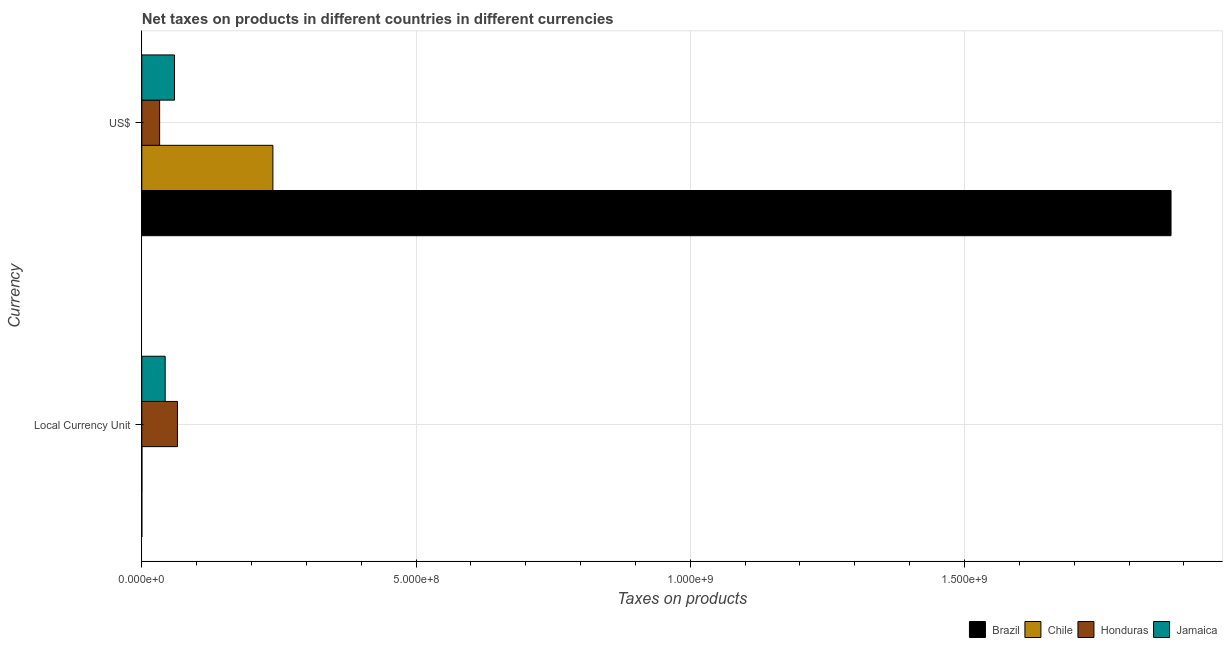How many different coloured bars are there?
Keep it short and to the point. 4. How many groups of bars are there?
Offer a terse response. 2. Are the number of bars per tick equal to the number of legend labels?
Give a very brief answer. Yes. How many bars are there on the 1st tick from the top?
Offer a very short reply. 4. How many bars are there on the 2nd tick from the bottom?
Your response must be concise. 4. What is the label of the 1st group of bars from the top?
Your answer should be very brief. US$. What is the net taxes in us$ in Honduras?
Your answer should be compact. 3.25e+07. Across all countries, what is the maximum net taxes in constant 2005 us$?
Make the answer very short. 6.50e+07. Across all countries, what is the minimum net taxes in us$?
Your answer should be very brief. 3.25e+07. In which country was the net taxes in constant 2005 us$ maximum?
Make the answer very short. Honduras. In which country was the net taxes in constant 2005 us$ minimum?
Give a very brief answer. Brazil. What is the total net taxes in constant 2005 us$ in the graph?
Your answer should be compact. 1.08e+08. What is the difference between the net taxes in constant 2005 us$ in Brazil and that in Chile?
Keep it short and to the point. -2.53e+05. What is the difference between the net taxes in constant 2005 us$ in Brazil and the net taxes in us$ in Chile?
Keep it short and to the point. -2.39e+08. What is the average net taxes in us$ per country?
Offer a terse response. 5.52e+08. What is the difference between the net taxes in us$ and net taxes in constant 2005 us$ in Honduras?
Your answer should be compact. -3.25e+07. What is the ratio of the net taxes in constant 2005 us$ in Chile to that in Honduras?
Offer a terse response. 0. Is the net taxes in constant 2005 us$ in Honduras less than that in Jamaica?
Ensure brevity in your answer.  No. In how many countries, is the net taxes in constant 2005 us$ greater than the average net taxes in constant 2005 us$ taken over all countries?
Your response must be concise. 2. What does the 2nd bar from the top in US$ represents?
Provide a succinct answer. Honduras. What does the 3rd bar from the bottom in US$ represents?
Provide a short and direct response. Honduras. How many bars are there?
Give a very brief answer. 8. How many countries are there in the graph?
Provide a succinct answer. 4. What is the difference between two consecutive major ticks on the X-axis?
Your answer should be very brief. 5.00e+08. Are the values on the major ticks of X-axis written in scientific E-notation?
Your response must be concise. Yes. Does the graph contain any zero values?
Offer a terse response. No. Does the graph contain grids?
Provide a succinct answer. Yes. Where does the legend appear in the graph?
Offer a terse response. Bottom right. How are the legend labels stacked?
Your response must be concise. Horizontal. What is the title of the graph?
Keep it short and to the point. Net taxes on products in different countries in different currencies. What is the label or title of the X-axis?
Give a very brief answer. Taxes on products. What is the label or title of the Y-axis?
Your response must be concise. Currency. What is the Taxes on products of Brazil in Local Currency Unit?
Ensure brevity in your answer.  0. What is the Taxes on products of Chile in Local Currency Unit?
Ensure brevity in your answer.  2.53e+05. What is the Taxes on products of Honduras in Local Currency Unit?
Keep it short and to the point. 6.50e+07. What is the Taxes on products of Jamaica in Local Currency Unit?
Keep it short and to the point. 4.26e+07. What is the Taxes on products in Brazil in US$?
Offer a very short reply. 1.88e+09. What is the Taxes on products in Chile in US$?
Provide a succinct answer. 2.39e+08. What is the Taxes on products of Honduras in US$?
Give a very brief answer. 3.25e+07. What is the Taxes on products in Jamaica in US$?
Your answer should be compact. 5.96e+07. Across all Currency, what is the maximum Taxes on products in Brazil?
Provide a short and direct response. 1.88e+09. Across all Currency, what is the maximum Taxes on products of Chile?
Ensure brevity in your answer.  2.39e+08. Across all Currency, what is the maximum Taxes on products in Honduras?
Your answer should be compact. 6.50e+07. Across all Currency, what is the maximum Taxes on products in Jamaica?
Your answer should be compact. 5.96e+07. Across all Currency, what is the minimum Taxes on products in Brazil?
Your answer should be very brief. 0. Across all Currency, what is the minimum Taxes on products of Chile?
Give a very brief answer. 2.53e+05. Across all Currency, what is the minimum Taxes on products of Honduras?
Make the answer very short. 3.25e+07. Across all Currency, what is the minimum Taxes on products of Jamaica?
Your answer should be very brief. 4.26e+07. What is the total Taxes on products in Brazil in the graph?
Ensure brevity in your answer.  1.88e+09. What is the total Taxes on products of Chile in the graph?
Keep it short and to the point. 2.39e+08. What is the total Taxes on products of Honduras in the graph?
Your answer should be compact. 9.75e+07. What is the total Taxes on products in Jamaica in the graph?
Provide a short and direct response. 1.02e+08. What is the difference between the Taxes on products in Brazil in Local Currency Unit and that in US$?
Give a very brief answer. -1.88e+09. What is the difference between the Taxes on products of Chile in Local Currency Unit and that in US$?
Your answer should be compact. -2.39e+08. What is the difference between the Taxes on products in Honduras in Local Currency Unit and that in US$?
Your answer should be compact. 3.25e+07. What is the difference between the Taxes on products of Jamaica in Local Currency Unit and that in US$?
Your answer should be compact. -1.70e+07. What is the difference between the Taxes on products of Brazil in Local Currency Unit and the Taxes on products of Chile in US$?
Make the answer very short. -2.39e+08. What is the difference between the Taxes on products of Brazil in Local Currency Unit and the Taxes on products of Honduras in US$?
Your answer should be very brief. -3.25e+07. What is the difference between the Taxes on products in Brazil in Local Currency Unit and the Taxes on products in Jamaica in US$?
Offer a very short reply. -5.96e+07. What is the difference between the Taxes on products in Chile in Local Currency Unit and the Taxes on products in Honduras in US$?
Make the answer very short. -3.22e+07. What is the difference between the Taxes on products in Chile in Local Currency Unit and the Taxes on products in Jamaica in US$?
Offer a very short reply. -5.94e+07. What is the difference between the Taxes on products in Honduras in Local Currency Unit and the Taxes on products in Jamaica in US$?
Offer a very short reply. 5.36e+06. What is the average Taxes on products in Brazil per Currency?
Offer a very short reply. 9.38e+08. What is the average Taxes on products in Chile per Currency?
Your response must be concise. 1.20e+08. What is the average Taxes on products of Honduras per Currency?
Your answer should be compact. 4.88e+07. What is the average Taxes on products in Jamaica per Currency?
Provide a succinct answer. 5.11e+07. What is the difference between the Taxes on products in Brazil and Taxes on products in Chile in Local Currency Unit?
Give a very brief answer. -2.53e+05. What is the difference between the Taxes on products in Brazil and Taxes on products in Honduras in Local Currency Unit?
Give a very brief answer. -6.50e+07. What is the difference between the Taxes on products of Brazil and Taxes on products of Jamaica in Local Currency Unit?
Give a very brief answer. -4.26e+07. What is the difference between the Taxes on products of Chile and Taxes on products of Honduras in Local Currency Unit?
Provide a succinct answer. -6.47e+07. What is the difference between the Taxes on products of Chile and Taxes on products of Jamaica in Local Currency Unit?
Provide a succinct answer. -4.23e+07. What is the difference between the Taxes on products of Honduras and Taxes on products of Jamaica in Local Currency Unit?
Ensure brevity in your answer.  2.24e+07. What is the difference between the Taxes on products of Brazil and Taxes on products of Chile in US$?
Offer a very short reply. 1.64e+09. What is the difference between the Taxes on products in Brazil and Taxes on products in Honduras in US$?
Your response must be concise. 1.84e+09. What is the difference between the Taxes on products of Brazil and Taxes on products of Jamaica in US$?
Provide a succinct answer. 1.82e+09. What is the difference between the Taxes on products of Chile and Taxes on products of Honduras in US$?
Offer a very short reply. 2.07e+08. What is the difference between the Taxes on products in Chile and Taxes on products in Jamaica in US$?
Your answer should be compact. 1.79e+08. What is the difference between the Taxes on products in Honduras and Taxes on products in Jamaica in US$?
Your response must be concise. -2.71e+07. What is the ratio of the Taxes on products in Chile in Local Currency Unit to that in US$?
Provide a succinct answer. 0. What is the ratio of the Taxes on products of Honduras in Local Currency Unit to that in US$?
Keep it short and to the point. 2. What is the ratio of the Taxes on products of Jamaica in Local Currency Unit to that in US$?
Your answer should be compact. 0.71. What is the difference between the highest and the second highest Taxes on products of Brazil?
Ensure brevity in your answer.  1.88e+09. What is the difference between the highest and the second highest Taxes on products of Chile?
Keep it short and to the point. 2.39e+08. What is the difference between the highest and the second highest Taxes on products in Honduras?
Your response must be concise. 3.25e+07. What is the difference between the highest and the second highest Taxes on products of Jamaica?
Provide a short and direct response. 1.70e+07. What is the difference between the highest and the lowest Taxes on products of Brazil?
Offer a very short reply. 1.88e+09. What is the difference between the highest and the lowest Taxes on products in Chile?
Provide a succinct answer. 2.39e+08. What is the difference between the highest and the lowest Taxes on products of Honduras?
Provide a short and direct response. 3.25e+07. What is the difference between the highest and the lowest Taxes on products in Jamaica?
Make the answer very short. 1.70e+07. 